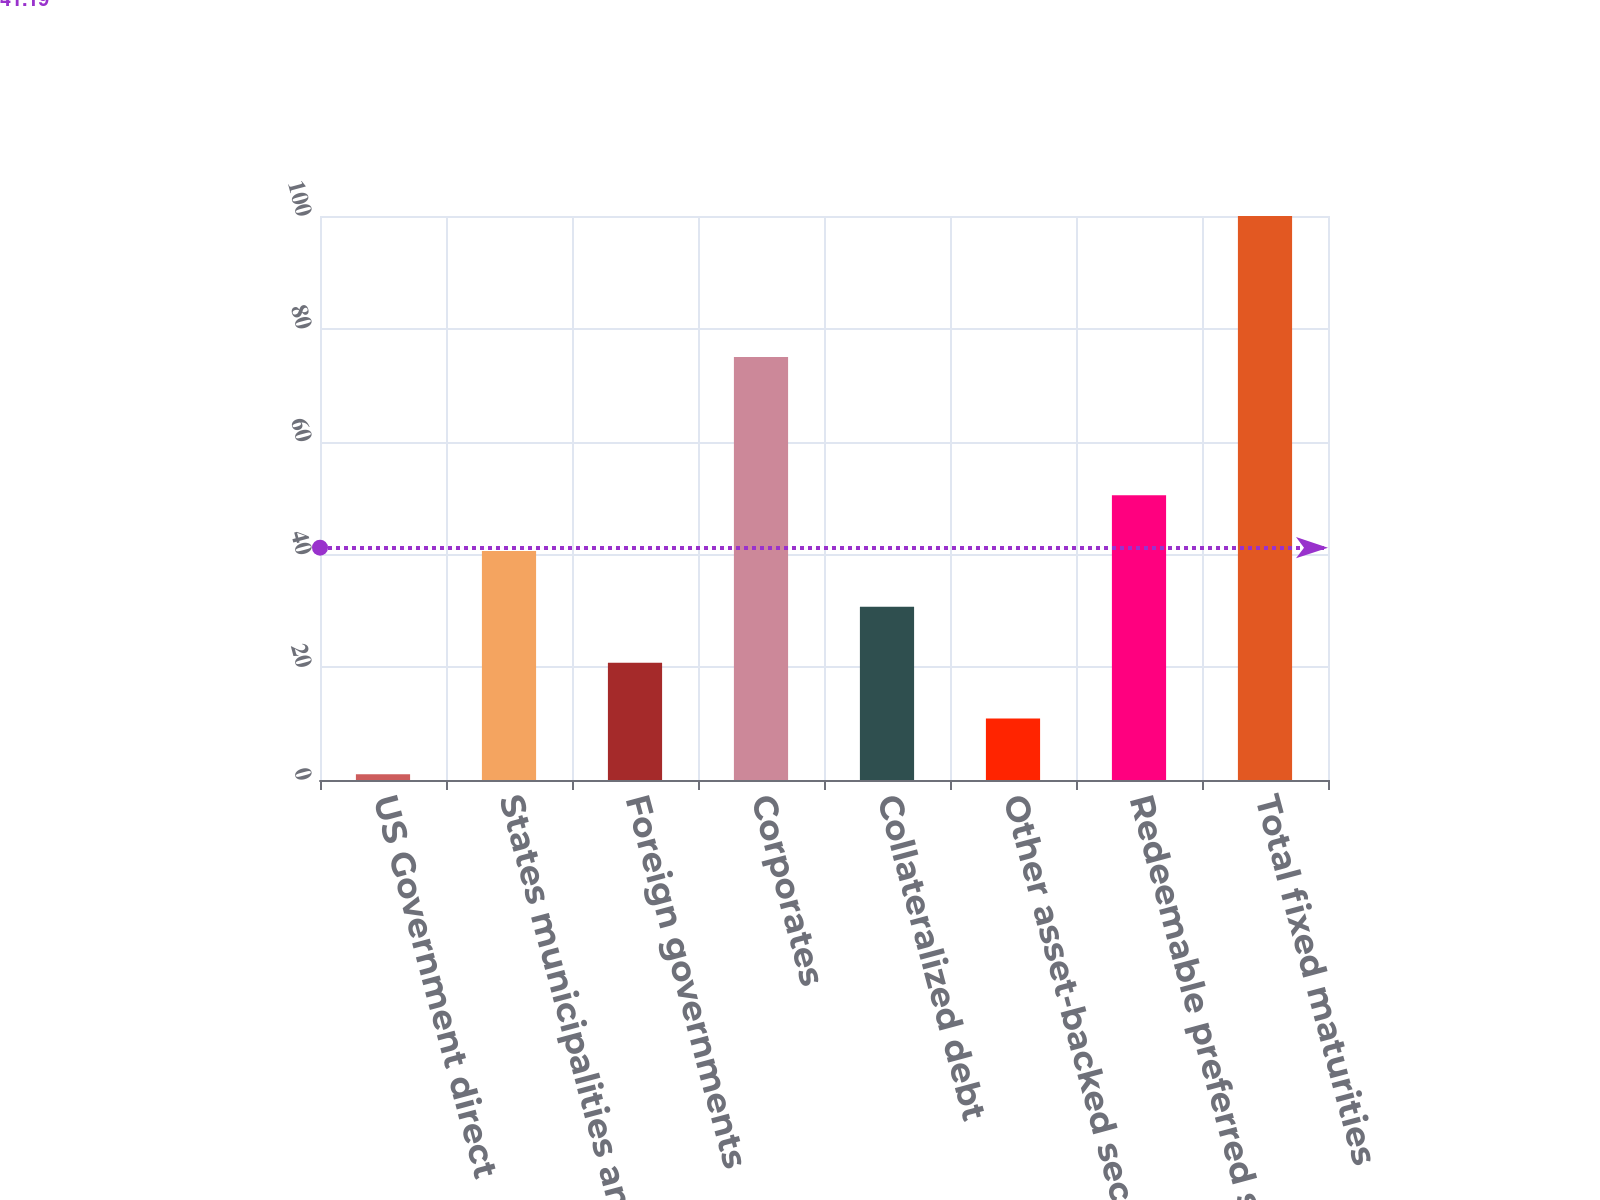Convert chart to OTSL. <chart><loc_0><loc_0><loc_500><loc_500><bar_chart><fcel>US Government direct<fcel>States municipalities and<fcel>Foreign governments<fcel>Corporates<fcel>Collateralized debt<fcel>Other asset-backed securities<fcel>Redeemable preferred stocks<fcel>Total fixed maturities<nl><fcel>1<fcel>40.6<fcel>20.8<fcel>75<fcel>30.7<fcel>10.9<fcel>50.5<fcel>100<nl></chart> 